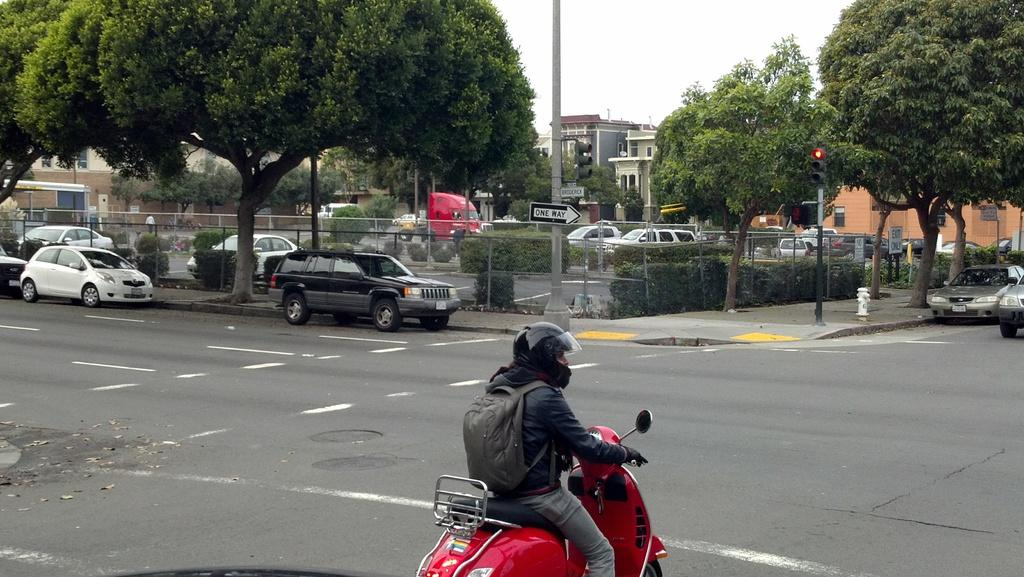What is the man in the image doing? The man is sitting on a bike in the image. What can be seen in the background of the image? There are cars, trees, trucks, buildings, a pole, and the sky visible in the background of the image. What type of kite is the man flying in the image? There is no kite present in the image; the man is sitting on a bike. 